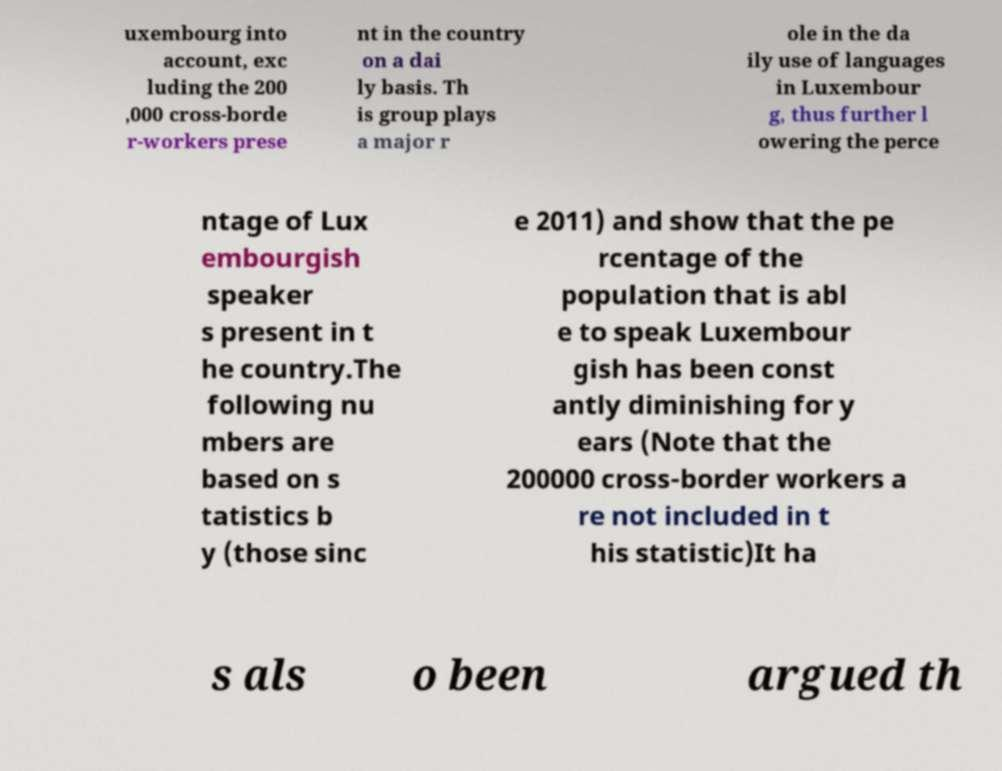I need the written content from this picture converted into text. Can you do that? uxembourg into account, exc luding the 200 ,000 cross-borde r-workers prese nt in the country on a dai ly basis. Th is group plays a major r ole in the da ily use of languages in Luxembour g, thus further l owering the perce ntage of Lux embourgish speaker s present in t he country.The following nu mbers are based on s tatistics b y (those sinc e 2011) and show that the pe rcentage of the population that is abl e to speak Luxembour gish has been const antly diminishing for y ears (Note that the 200000 cross-border workers a re not included in t his statistic)It ha s als o been argued th 